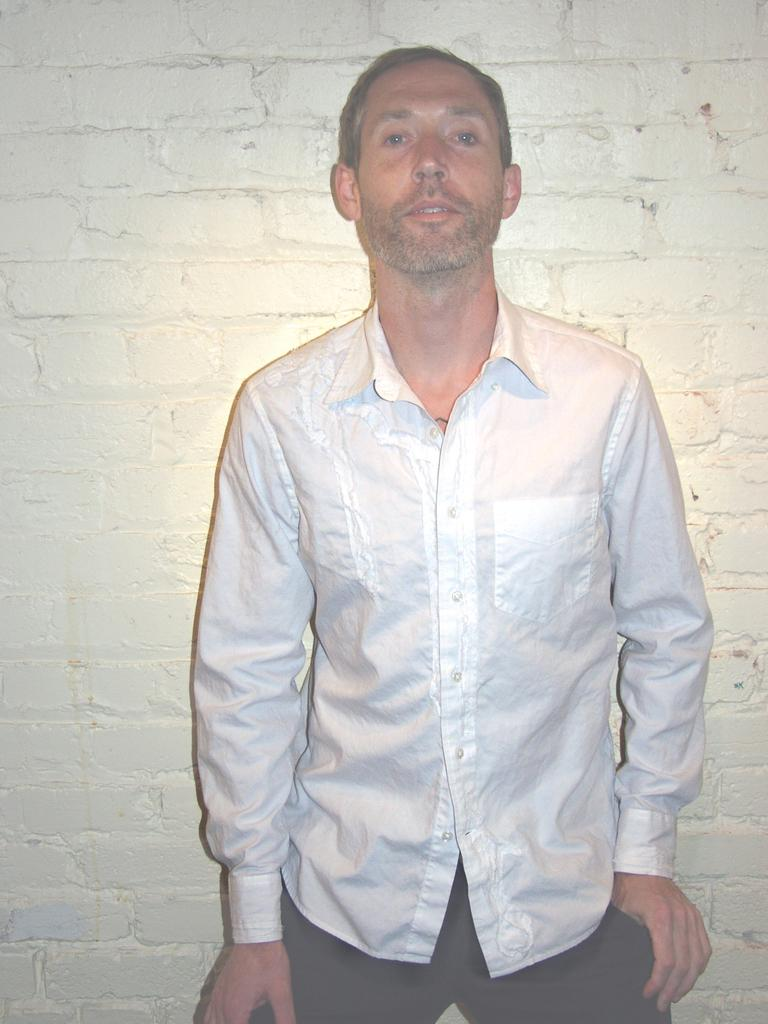What is the main subject of the image? There is a person standing in the image. What is the person wearing? The person is wearing a white and black dress. What can be seen in the background of the image? There is a white wall visible in the image. What type of underwear is the person wearing in the image? The provided facts do not mention any underwear, so it cannot be determined from the image. 